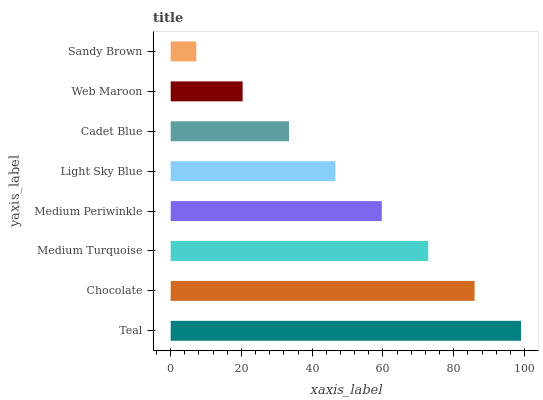Is Sandy Brown the minimum?
Answer yes or no. Yes. Is Teal the maximum?
Answer yes or no. Yes. Is Chocolate the minimum?
Answer yes or no. No. Is Chocolate the maximum?
Answer yes or no. No. Is Teal greater than Chocolate?
Answer yes or no. Yes. Is Chocolate less than Teal?
Answer yes or no. Yes. Is Chocolate greater than Teal?
Answer yes or no. No. Is Teal less than Chocolate?
Answer yes or no. No. Is Medium Periwinkle the high median?
Answer yes or no. Yes. Is Light Sky Blue the low median?
Answer yes or no. Yes. Is Cadet Blue the high median?
Answer yes or no. No. Is Web Maroon the low median?
Answer yes or no. No. 